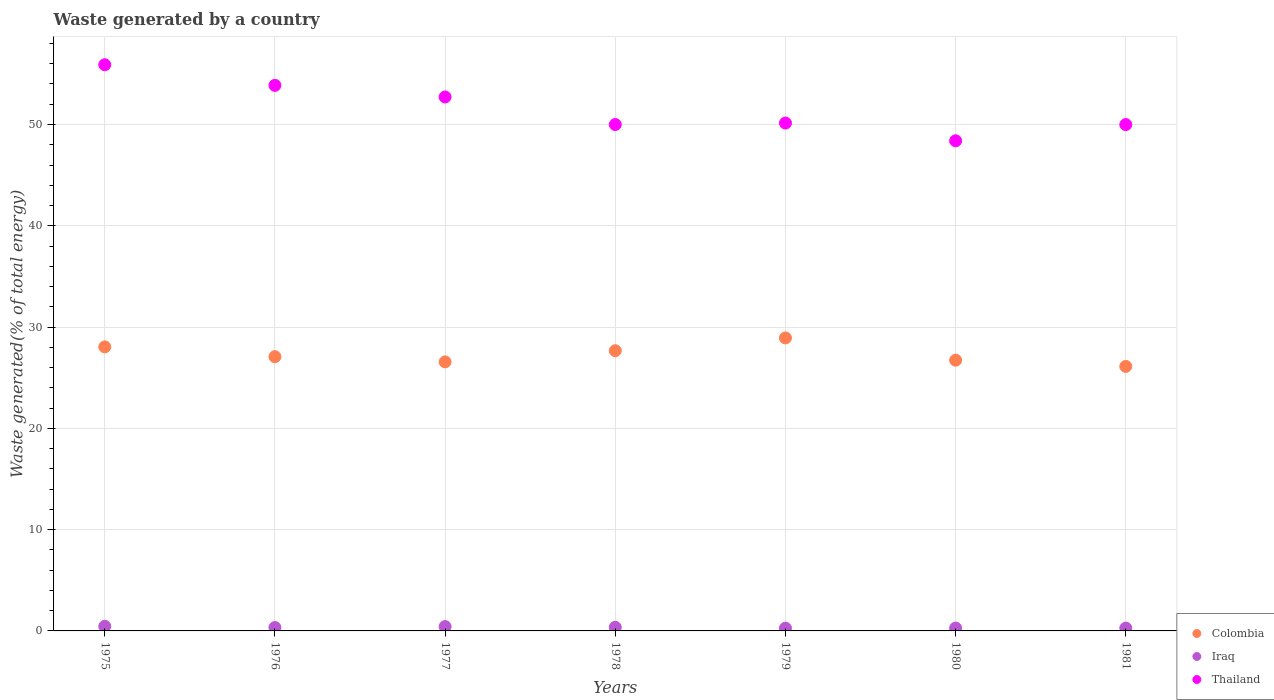Is the number of dotlines equal to the number of legend labels?
Your response must be concise. Yes. What is the total waste generated in Iraq in 1976?
Offer a very short reply. 0.34. Across all years, what is the maximum total waste generated in Colombia?
Offer a very short reply. 28.93. Across all years, what is the minimum total waste generated in Iraq?
Your response must be concise. 0.27. In which year was the total waste generated in Iraq maximum?
Offer a very short reply. 1975. What is the total total waste generated in Iraq in the graph?
Your response must be concise. 2.41. What is the difference between the total waste generated in Colombia in 1975 and that in 1979?
Offer a very short reply. -0.88. What is the difference between the total waste generated in Thailand in 1979 and the total waste generated in Colombia in 1978?
Keep it short and to the point. 22.47. What is the average total waste generated in Thailand per year?
Make the answer very short. 51.57. In the year 1978, what is the difference between the total waste generated in Thailand and total waste generated in Colombia?
Provide a succinct answer. 22.33. In how many years, is the total waste generated in Colombia greater than 10 %?
Give a very brief answer. 7. What is the ratio of the total waste generated in Iraq in 1977 to that in 1981?
Keep it short and to the point. 1.55. What is the difference between the highest and the second highest total waste generated in Thailand?
Ensure brevity in your answer.  2.04. What is the difference between the highest and the lowest total waste generated in Thailand?
Offer a very short reply. 7.51. In how many years, is the total waste generated in Iraq greater than the average total waste generated in Iraq taken over all years?
Provide a succinct answer. 3. Is the sum of the total waste generated in Iraq in 1979 and 1981 greater than the maximum total waste generated in Colombia across all years?
Your response must be concise. No. Is the total waste generated in Iraq strictly greater than the total waste generated in Colombia over the years?
Your response must be concise. No. Is the total waste generated in Thailand strictly less than the total waste generated in Colombia over the years?
Your response must be concise. No. How many dotlines are there?
Your response must be concise. 3. How many years are there in the graph?
Ensure brevity in your answer.  7. What is the difference between two consecutive major ticks on the Y-axis?
Ensure brevity in your answer.  10. Where does the legend appear in the graph?
Provide a short and direct response. Bottom right. How many legend labels are there?
Ensure brevity in your answer.  3. What is the title of the graph?
Offer a terse response. Waste generated by a country. What is the label or title of the Y-axis?
Your response must be concise. Waste generated(% of total energy). What is the Waste generated(% of total energy) of Colombia in 1975?
Provide a succinct answer. 28.04. What is the Waste generated(% of total energy) in Iraq in 1975?
Your answer should be compact. 0.45. What is the Waste generated(% of total energy) of Thailand in 1975?
Provide a succinct answer. 55.9. What is the Waste generated(% of total energy) of Colombia in 1976?
Offer a very short reply. 27.08. What is the Waste generated(% of total energy) in Iraq in 1976?
Your answer should be compact. 0.34. What is the Waste generated(% of total energy) in Thailand in 1976?
Keep it short and to the point. 53.86. What is the Waste generated(% of total energy) in Colombia in 1977?
Offer a terse response. 26.56. What is the Waste generated(% of total energy) of Iraq in 1977?
Keep it short and to the point. 0.43. What is the Waste generated(% of total energy) of Thailand in 1977?
Give a very brief answer. 52.72. What is the Waste generated(% of total energy) in Colombia in 1978?
Keep it short and to the point. 27.67. What is the Waste generated(% of total energy) of Iraq in 1978?
Offer a terse response. 0.36. What is the Waste generated(% of total energy) in Thailand in 1978?
Your answer should be compact. 50. What is the Waste generated(% of total energy) of Colombia in 1979?
Make the answer very short. 28.93. What is the Waste generated(% of total energy) in Iraq in 1979?
Keep it short and to the point. 0.27. What is the Waste generated(% of total energy) of Thailand in 1979?
Your answer should be compact. 50.14. What is the Waste generated(% of total energy) of Colombia in 1980?
Provide a succinct answer. 26.73. What is the Waste generated(% of total energy) in Iraq in 1980?
Provide a short and direct response. 0.28. What is the Waste generated(% of total energy) of Thailand in 1980?
Give a very brief answer. 48.39. What is the Waste generated(% of total energy) in Colombia in 1981?
Give a very brief answer. 26.12. What is the Waste generated(% of total energy) in Iraq in 1981?
Keep it short and to the point. 0.28. What is the Waste generated(% of total energy) in Thailand in 1981?
Offer a terse response. 49.99. Across all years, what is the maximum Waste generated(% of total energy) in Colombia?
Offer a terse response. 28.93. Across all years, what is the maximum Waste generated(% of total energy) of Iraq?
Give a very brief answer. 0.45. Across all years, what is the maximum Waste generated(% of total energy) in Thailand?
Ensure brevity in your answer.  55.9. Across all years, what is the minimum Waste generated(% of total energy) of Colombia?
Your answer should be very brief. 26.12. Across all years, what is the minimum Waste generated(% of total energy) of Iraq?
Offer a very short reply. 0.27. Across all years, what is the minimum Waste generated(% of total energy) of Thailand?
Offer a terse response. 48.39. What is the total Waste generated(% of total energy) in Colombia in the graph?
Keep it short and to the point. 191.12. What is the total Waste generated(% of total energy) of Iraq in the graph?
Your response must be concise. 2.41. What is the total Waste generated(% of total energy) in Thailand in the graph?
Give a very brief answer. 361. What is the difference between the Waste generated(% of total energy) of Colombia in 1975 and that in 1976?
Your answer should be compact. 0.97. What is the difference between the Waste generated(% of total energy) of Iraq in 1975 and that in 1976?
Your answer should be very brief. 0.12. What is the difference between the Waste generated(% of total energy) in Thailand in 1975 and that in 1976?
Give a very brief answer. 2.04. What is the difference between the Waste generated(% of total energy) in Colombia in 1975 and that in 1977?
Make the answer very short. 1.48. What is the difference between the Waste generated(% of total energy) in Iraq in 1975 and that in 1977?
Keep it short and to the point. 0.02. What is the difference between the Waste generated(% of total energy) in Thailand in 1975 and that in 1977?
Keep it short and to the point. 3.18. What is the difference between the Waste generated(% of total energy) of Colombia in 1975 and that in 1978?
Your response must be concise. 0.38. What is the difference between the Waste generated(% of total energy) of Iraq in 1975 and that in 1978?
Make the answer very short. 0.1. What is the difference between the Waste generated(% of total energy) of Thailand in 1975 and that in 1978?
Ensure brevity in your answer.  5.9. What is the difference between the Waste generated(% of total energy) of Colombia in 1975 and that in 1979?
Make the answer very short. -0.88. What is the difference between the Waste generated(% of total energy) in Iraq in 1975 and that in 1979?
Give a very brief answer. 0.18. What is the difference between the Waste generated(% of total energy) of Thailand in 1975 and that in 1979?
Provide a succinct answer. 5.76. What is the difference between the Waste generated(% of total energy) in Colombia in 1975 and that in 1980?
Your response must be concise. 1.31. What is the difference between the Waste generated(% of total energy) in Iraq in 1975 and that in 1980?
Give a very brief answer. 0.17. What is the difference between the Waste generated(% of total energy) of Thailand in 1975 and that in 1980?
Keep it short and to the point. 7.51. What is the difference between the Waste generated(% of total energy) in Colombia in 1975 and that in 1981?
Ensure brevity in your answer.  1.93. What is the difference between the Waste generated(% of total energy) of Iraq in 1975 and that in 1981?
Keep it short and to the point. 0.18. What is the difference between the Waste generated(% of total energy) of Thailand in 1975 and that in 1981?
Ensure brevity in your answer.  5.91. What is the difference between the Waste generated(% of total energy) of Colombia in 1976 and that in 1977?
Offer a very short reply. 0.51. What is the difference between the Waste generated(% of total energy) of Iraq in 1976 and that in 1977?
Your answer should be very brief. -0.1. What is the difference between the Waste generated(% of total energy) of Thailand in 1976 and that in 1977?
Your answer should be very brief. 1.15. What is the difference between the Waste generated(% of total energy) of Colombia in 1976 and that in 1978?
Provide a short and direct response. -0.59. What is the difference between the Waste generated(% of total energy) in Iraq in 1976 and that in 1978?
Provide a short and direct response. -0.02. What is the difference between the Waste generated(% of total energy) of Thailand in 1976 and that in 1978?
Make the answer very short. 3.87. What is the difference between the Waste generated(% of total energy) of Colombia in 1976 and that in 1979?
Ensure brevity in your answer.  -1.85. What is the difference between the Waste generated(% of total energy) in Iraq in 1976 and that in 1979?
Ensure brevity in your answer.  0.06. What is the difference between the Waste generated(% of total energy) in Thailand in 1976 and that in 1979?
Provide a succinct answer. 3.72. What is the difference between the Waste generated(% of total energy) in Colombia in 1976 and that in 1980?
Your response must be concise. 0.35. What is the difference between the Waste generated(% of total energy) of Iraq in 1976 and that in 1980?
Your answer should be very brief. 0.05. What is the difference between the Waste generated(% of total energy) in Thailand in 1976 and that in 1980?
Ensure brevity in your answer.  5.47. What is the difference between the Waste generated(% of total energy) in Colombia in 1976 and that in 1981?
Give a very brief answer. 0.96. What is the difference between the Waste generated(% of total energy) of Iraq in 1976 and that in 1981?
Your answer should be very brief. 0.06. What is the difference between the Waste generated(% of total energy) in Thailand in 1976 and that in 1981?
Your answer should be compact. 3.87. What is the difference between the Waste generated(% of total energy) in Colombia in 1977 and that in 1978?
Offer a very short reply. -1.1. What is the difference between the Waste generated(% of total energy) in Iraq in 1977 and that in 1978?
Keep it short and to the point. 0.07. What is the difference between the Waste generated(% of total energy) of Thailand in 1977 and that in 1978?
Provide a succinct answer. 2.72. What is the difference between the Waste generated(% of total energy) of Colombia in 1977 and that in 1979?
Your answer should be very brief. -2.36. What is the difference between the Waste generated(% of total energy) of Iraq in 1977 and that in 1979?
Provide a succinct answer. 0.16. What is the difference between the Waste generated(% of total energy) of Thailand in 1977 and that in 1979?
Your answer should be compact. 2.57. What is the difference between the Waste generated(% of total energy) in Colombia in 1977 and that in 1980?
Keep it short and to the point. -0.17. What is the difference between the Waste generated(% of total energy) in Iraq in 1977 and that in 1980?
Make the answer very short. 0.15. What is the difference between the Waste generated(% of total energy) in Thailand in 1977 and that in 1980?
Provide a succinct answer. 4.33. What is the difference between the Waste generated(% of total energy) of Colombia in 1977 and that in 1981?
Ensure brevity in your answer.  0.45. What is the difference between the Waste generated(% of total energy) in Iraq in 1977 and that in 1981?
Make the answer very short. 0.15. What is the difference between the Waste generated(% of total energy) in Thailand in 1977 and that in 1981?
Offer a terse response. 2.73. What is the difference between the Waste generated(% of total energy) in Colombia in 1978 and that in 1979?
Offer a terse response. -1.26. What is the difference between the Waste generated(% of total energy) of Iraq in 1978 and that in 1979?
Provide a succinct answer. 0.09. What is the difference between the Waste generated(% of total energy) of Thailand in 1978 and that in 1979?
Make the answer very short. -0.14. What is the difference between the Waste generated(% of total energy) in Colombia in 1978 and that in 1980?
Provide a succinct answer. 0.94. What is the difference between the Waste generated(% of total energy) of Iraq in 1978 and that in 1980?
Your answer should be very brief. 0.08. What is the difference between the Waste generated(% of total energy) of Thailand in 1978 and that in 1980?
Ensure brevity in your answer.  1.61. What is the difference between the Waste generated(% of total energy) of Colombia in 1978 and that in 1981?
Your response must be concise. 1.55. What is the difference between the Waste generated(% of total energy) in Iraq in 1978 and that in 1981?
Offer a very short reply. 0.08. What is the difference between the Waste generated(% of total energy) in Thailand in 1978 and that in 1981?
Provide a succinct answer. 0.01. What is the difference between the Waste generated(% of total energy) in Colombia in 1979 and that in 1980?
Provide a short and direct response. 2.2. What is the difference between the Waste generated(% of total energy) of Iraq in 1979 and that in 1980?
Your response must be concise. -0.01. What is the difference between the Waste generated(% of total energy) of Thailand in 1979 and that in 1980?
Make the answer very short. 1.75. What is the difference between the Waste generated(% of total energy) in Colombia in 1979 and that in 1981?
Your answer should be very brief. 2.81. What is the difference between the Waste generated(% of total energy) of Iraq in 1979 and that in 1981?
Offer a very short reply. -0.01. What is the difference between the Waste generated(% of total energy) in Thailand in 1979 and that in 1981?
Your answer should be very brief. 0.15. What is the difference between the Waste generated(% of total energy) of Colombia in 1980 and that in 1981?
Ensure brevity in your answer.  0.61. What is the difference between the Waste generated(% of total energy) in Iraq in 1980 and that in 1981?
Give a very brief answer. 0.01. What is the difference between the Waste generated(% of total energy) of Thailand in 1980 and that in 1981?
Your answer should be very brief. -1.6. What is the difference between the Waste generated(% of total energy) of Colombia in 1975 and the Waste generated(% of total energy) of Iraq in 1976?
Your answer should be compact. 27.71. What is the difference between the Waste generated(% of total energy) in Colombia in 1975 and the Waste generated(% of total energy) in Thailand in 1976?
Ensure brevity in your answer.  -25.82. What is the difference between the Waste generated(% of total energy) of Iraq in 1975 and the Waste generated(% of total energy) of Thailand in 1976?
Provide a succinct answer. -53.41. What is the difference between the Waste generated(% of total energy) of Colombia in 1975 and the Waste generated(% of total energy) of Iraq in 1977?
Offer a very short reply. 27.61. What is the difference between the Waste generated(% of total energy) of Colombia in 1975 and the Waste generated(% of total energy) of Thailand in 1977?
Your response must be concise. -24.67. What is the difference between the Waste generated(% of total energy) in Iraq in 1975 and the Waste generated(% of total energy) in Thailand in 1977?
Give a very brief answer. -52.26. What is the difference between the Waste generated(% of total energy) of Colombia in 1975 and the Waste generated(% of total energy) of Iraq in 1978?
Offer a terse response. 27.68. What is the difference between the Waste generated(% of total energy) of Colombia in 1975 and the Waste generated(% of total energy) of Thailand in 1978?
Provide a succinct answer. -21.95. What is the difference between the Waste generated(% of total energy) in Iraq in 1975 and the Waste generated(% of total energy) in Thailand in 1978?
Ensure brevity in your answer.  -49.54. What is the difference between the Waste generated(% of total energy) of Colombia in 1975 and the Waste generated(% of total energy) of Iraq in 1979?
Provide a short and direct response. 27.77. What is the difference between the Waste generated(% of total energy) in Colombia in 1975 and the Waste generated(% of total energy) in Thailand in 1979?
Ensure brevity in your answer.  -22.1. What is the difference between the Waste generated(% of total energy) of Iraq in 1975 and the Waste generated(% of total energy) of Thailand in 1979?
Provide a short and direct response. -49.69. What is the difference between the Waste generated(% of total energy) of Colombia in 1975 and the Waste generated(% of total energy) of Iraq in 1980?
Your response must be concise. 27.76. What is the difference between the Waste generated(% of total energy) in Colombia in 1975 and the Waste generated(% of total energy) in Thailand in 1980?
Ensure brevity in your answer.  -20.35. What is the difference between the Waste generated(% of total energy) in Iraq in 1975 and the Waste generated(% of total energy) in Thailand in 1980?
Ensure brevity in your answer.  -47.94. What is the difference between the Waste generated(% of total energy) of Colombia in 1975 and the Waste generated(% of total energy) of Iraq in 1981?
Offer a terse response. 27.77. What is the difference between the Waste generated(% of total energy) of Colombia in 1975 and the Waste generated(% of total energy) of Thailand in 1981?
Provide a succinct answer. -21.95. What is the difference between the Waste generated(% of total energy) in Iraq in 1975 and the Waste generated(% of total energy) in Thailand in 1981?
Your answer should be very brief. -49.54. What is the difference between the Waste generated(% of total energy) in Colombia in 1976 and the Waste generated(% of total energy) in Iraq in 1977?
Your answer should be very brief. 26.65. What is the difference between the Waste generated(% of total energy) in Colombia in 1976 and the Waste generated(% of total energy) in Thailand in 1977?
Give a very brief answer. -25.64. What is the difference between the Waste generated(% of total energy) in Iraq in 1976 and the Waste generated(% of total energy) in Thailand in 1977?
Keep it short and to the point. -52.38. What is the difference between the Waste generated(% of total energy) in Colombia in 1976 and the Waste generated(% of total energy) in Iraq in 1978?
Your response must be concise. 26.72. What is the difference between the Waste generated(% of total energy) of Colombia in 1976 and the Waste generated(% of total energy) of Thailand in 1978?
Offer a very short reply. -22.92. What is the difference between the Waste generated(% of total energy) of Iraq in 1976 and the Waste generated(% of total energy) of Thailand in 1978?
Offer a very short reply. -49.66. What is the difference between the Waste generated(% of total energy) of Colombia in 1976 and the Waste generated(% of total energy) of Iraq in 1979?
Provide a succinct answer. 26.8. What is the difference between the Waste generated(% of total energy) in Colombia in 1976 and the Waste generated(% of total energy) in Thailand in 1979?
Provide a succinct answer. -23.07. What is the difference between the Waste generated(% of total energy) in Iraq in 1976 and the Waste generated(% of total energy) in Thailand in 1979?
Provide a short and direct response. -49.81. What is the difference between the Waste generated(% of total energy) in Colombia in 1976 and the Waste generated(% of total energy) in Iraq in 1980?
Your answer should be very brief. 26.79. What is the difference between the Waste generated(% of total energy) of Colombia in 1976 and the Waste generated(% of total energy) of Thailand in 1980?
Give a very brief answer. -21.31. What is the difference between the Waste generated(% of total energy) of Iraq in 1976 and the Waste generated(% of total energy) of Thailand in 1980?
Provide a short and direct response. -48.06. What is the difference between the Waste generated(% of total energy) in Colombia in 1976 and the Waste generated(% of total energy) in Iraq in 1981?
Give a very brief answer. 26.8. What is the difference between the Waste generated(% of total energy) of Colombia in 1976 and the Waste generated(% of total energy) of Thailand in 1981?
Your answer should be very brief. -22.92. What is the difference between the Waste generated(% of total energy) in Iraq in 1976 and the Waste generated(% of total energy) in Thailand in 1981?
Give a very brief answer. -49.66. What is the difference between the Waste generated(% of total energy) of Colombia in 1977 and the Waste generated(% of total energy) of Iraq in 1978?
Provide a succinct answer. 26.2. What is the difference between the Waste generated(% of total energy) in Colombia in 1977 and the Waste generated(% of total energy) in Thailand in 1978?
Your answer should be compact. -23.44. What is the difference between the Waste generated(% of total energy) in Iraq in 1977 and the Waste generated(% of total energy) in Thailand in 1978?
Your answer should be compact. -49.57. What is the difference between the Waste generated(% of total energy) in Colombia in 1977 and the Waste generated(% of total energy) in Iraq in 1979?
Ensure brevity in your answer.  26.29. What is the difference between the Waste generated(% of total energy) in Colombia in 1977 and the Waste generated(% of total energy) in Thailand in 1979?
Ensure brevity in your answer.  -23.58. What is the difference between the Waste generated(% of total energy) of Iraq in 1977 and the Waste generated(% of total energy) of Thailand in 1979?
Keep it short and to the point. -49.71. What is the difference between the Waste generated(% of total energy) of Colombia in 1977 and the Waste generated(% of total energy) of Iraq in 1980?
Give a very brief answer. 26.28. What is the difference between the Waste generated(% of total energy) in Colombia in 1977 and the Waste generated(% of total energy) in Thailand in 1980?
Keep it short and to the point. -21.83. What is the difference between the Waste generated(% of total energy) of Iraq in 1977 and the Waste generated(% of total energy) of Thailand in 1980?
Offer a very short reply. -47.96. What is the difference between the Waste generated(% of total energy) in Colombia in 1977 and the Waste generated(% of total energy) in Iraq in 1981?
Your answer should be compact. 26.29. What is the difference between the Waste generated(% of total energy) in Colombia in 1977 and the Waste generated(% of total energy) in Thailand in 1981?
Make the answer very short. -23.43. What is the difference between the Waste generated(% of total energy) of Iraq in 1977 and the Waste generated(% of total energy) of Thailand in 1981?
Make the answer very short. -49.56. What is the difference between the Waste generated(% of total energy) in Colombia in 1978 and the Waste generated(% of total energy) in Iraq in 1979?
Offer a very short reply. 27.4. What is the difference between the Waste generated(% of total energy) of Colombia in 1978 and the Waste generated(% of total energy) of Thailand in 1979?
Keep it short and to the point. -22.48. What is the difference between the Waste generated(% of total energy) of Iraq in 1978 and the Waste generated(% of total energy) of Thailand in 1979?
Provide a short and direct response. -49.78. What is the difference between the Waste generated(% of total energy) in Colombia in 1978 and the Waste generated(% of total energy) in Iraq in 1980?
Your answer should be very brief. 27.38. What is the difference between the Waste generated(% of total energy) in Colombia in 1978 and the Waste generated(% of total energy) in Thailand in 1980?
Ensure brevity in your answer.  -20.72. What is the difference between the Waste generated(% of total energy) of Iraq in 1978 and the Waste generated(% of total energy) of Thailand in 1980?
Keep it short and to the point. -48.03. What is the difference between the Waste generated(% of total energy) of Colombia in 1978 and the Waste generated(% of total energy) of Iraq in 1981?
Your response must be concise. 27.39. What is the difference between the Waste generated(% of total energy) of Colombia in 1978 and the Waste generated(% of total energy) of Thailand in 1981?
Provide a short and direct response. -22.32. What is the difference between the Waste generated(% of total energy) of Iraq in 1978 and the Waste generated(% of total energy) of Thailand in 1981?
Ensure brevity in your answer.  -49.63. What is the difference between the Waste generated(% of total energy) in Colombia in 1979 and the Waste generated(% of total energy) in Iraq in 1980?
Your answer should be compact. 28.64. What is the difference between the Waste generated(% of total energy) in Colombia in 1979 and the Waste generated(% of total energy) in Thailand in 1980?
Provide a succinct answer. -19.46. What is the difference between the Waste generated(% of total energy) of Iraq in 1979 and the Waste generated(% of total energy) of Thailand in 1980?
Give a very brief answer. -48.12. What is the difference between the Waste generated(% of total energy) of Colombia in 1979 and the Waste generated(% of total energy) of Iraq in 1981?
Make the answer very short. 28.65. What is the difference between the Waste generated(% of total energy) in Colombia in 1979 and the Waste generated(% of total energy) in Thailand in 1981?
Give a very brief answer. -21.06. What is the difference between the Waste generated(% of total energy) of Iraq in 1979 and the Waste generated(% of total energy) of Thailand in 1981?
Offer a very short reply. -49.72. What is the difference between the Waste generated(% of total energy) in Colombia in 1980 and the Waste generated(% of total energy) in Iraq in 1981?
Your response must be concise. 26.45. What is the difference between the Waste generated(% of total energy) of Colombia in 1980 and the Waste generated(% of total energy) of Thailand in 1981?
Give a very brief answer. -23.26. What is the difference between the Waste generated(% of total energy) in Iraq in 1980 and the Waste generated(% of total energy) in Thailand in 1981?
Ensure brevity in your answer.  -49.71. What is the average Waste generated(% of total energy) in Colombia per year?
Offer a terse response. 27.3. What is the average Waste generated(% of total energy) of Iraq per year?
Your response must be concise. 0.34. What is the average Waste generated(% of total energy) in Thailand per year?
Keep it short and to the point. 51.57. In the year 1975, what is the difference between the Waste generated(% of total energy) of Colombia and Waste generated(% of total energy) of Iraq?
Make the answer very short. 27.59. In the year 1975, what is the difference between the Waste generated(% of total energy) in Colombia and Waste generated(% of total energy) in Thailand?
Offer a very short reply. -27.86. In the year 1975, what is the difference between the Waste generated(% of total energy) in Iraq and Waste generated(% of total energy) in Thailand?
Provide a succinct answer. -55.44. In the year 1976, what is the difference between the Waste generated(% of total energy) in Colombia and Waste generated(% of total energy) in Iraq?
Give a very brief answer. 26.74. In the year 1976, what is the difference between the Waste generated(% of total energy) of Colombia and Waste generated(% of total energy) of Thailand?
Provide a short and direct response. -26.79. In the year 1976, what is the difference between the Waste generated(% of total energy) of Iraq and Waste generated(% of total energy) of Thailand?
Ensure brevity in your answer.  -53.53. In the year 1977, what is the difference between the Waste generated(% of total energy) in Colombia and Waste generated(% of total energy) in Iraq?
Keep it short and to the point. 26.13. In the year 1977, what is the difference between the Waste generated(% of total energy) in Colombia and Waste generated(% of total energy) in Thailand?
Keep it short and to the point. -26.15. In the year 1977, what is the difference between the Waste generated(% of total energy) in Iraq and Waste generated(% of total energy) in Thailand?
Provide a short and direct response. -52.29. In the year 1978, what is the difference between the Waste generated(% of total energy) of Colombia and Waste generated(% of total energy) of Iraq?
Your answer should be very brief. 27.31. In the year 1978, what is the difference between the Waste generated(% of total energy) of Colombia and Waste generated(% of total energy) of Thailand?
Provide a short and direct response. -22.33. In the year 1978, what is the difference between the Waste generated(% of total energy) in Iraq and Waste generated(% of total energy) in Thailand?
Ensure brevity in your answer.  -49.64. In the year 1979, what is the difference between the Waste generated(% of total energy) of Colombia and Waste generated(% of total energy) of Iraq?
Offer a terse response. 28.66. In the year 1979, what is the difference between the Waste generated(% of total energy) of Colombia and Waste generated(% of total energy) of Thailand?
Ensure brevity in your answer.  -21.22. In the year 1979, what is the difference between the Waste generated(% of total energy) in Iraq and Waste generated(% of total energy) in Thailand?
Offer a very short reply. -49.87. In the year 1980, what is the difference between the Waste generated(% of total energy) in Colombia and Waste generated(% of total energy) in Iraq?
Offer a very short reply. 26.45. In the year 1980, what is the difference between the Waste generated(% of total energy) of Colombia and Waste generated(% of total energy) of Thailand?
Provide a short and direct response. -21.66. In the year 1980, what is the difference between the Waste generated(% of total energy) of Iraq and Waste generated(% of total energy) of Thailand?
Give a very brief answer. -48.11. In the year 1981, what is the difference between the Waste generated(% of total energy) in Colombia and Waste generated(% of total energy) in Iraq?
Offer a terse response. 25.84. In the year 1981, what is the difference between the Waste generated(% of total energy) in Colombia and Waste generated(% of total energy) in Thailand?
Offer a terse response. -23.88. In the year 1981, what is the difference between the Waste generated(% of total energy) in Iraq and Waste generated(% of total energy) in Thailand?
Make the answer very short. -49.71. What is the ratio of the Waste generated(% of total energy) in Colombia in 1975 to that in 1976?
Make the answer very short. 1.04. What is the ratio of the Waste generated(% of total energy) of Iraq in 1975 to that in 1976?
Give a very brief answer. 1.35. What is the ratio of the Waste generated(% of total energy) of Thailand in 1975 to that in 1976?
Your response must be concise. 1.04. What is the ratio of the Waste generated(% of total energy) in Colombia in 1975 to that in 1977?
Provide a succinct answer. 1.06. What is the ratio of the Waste generated(% of total energy) in Iraq in 1975 to that in 1977?
Provide a short and direct response. 1.06. What is the ratio of the Waste generated(% of total energy) of Thailand in 1975 to that in 1977?
Offer a very short reply. 1.06. What is the ratio of the Waste generated(% of total energy) in Colombia in 1975 to that in 1978?
Provide a short and direct response. 1.01. What is the ratio of the Waste generated(% of total energy) of Iraq in 1975 to that in 1978?
Make the answer very short. 1.27. What is the ratio of the Waste generated(% of total energy) in Thailand in 1975 to that in 1978?
Offer a very short reply. 1.12. What is the ratio of the Waste generated(% of total energy) of Colombia in 1975 to that in 1979?
Your answer should be very brief. 0.97. What is the ratio of the Waste generated(% of total energy) of Iraq in 1975 to that in 1979?
Your response must be concise. 1.68. What is the ratio of the Waste generated(% of total energy) in Thailand in 1975 to that in 1979?
Provide a short and direct response. 1.11. What is the ratio of the Waste generated(% of total energy) of Colombia in 1975 to that in 1980?
Your answer should be compact. 1.05. What is the ratio of the Waste generated(% of total energy) of Iraq in 1975 to that in 1980?
Your response must be concise. 1.61. What is the ratio of the Waste generated(% of total energy) in Thailand in 1975 to that in 1980?
Make the answer very short. 1.16. What is the ratio of the Waste generated(% of total energy) in Colombia in 1975 to that in 1981?
Provide a short and direct response. 1.07. What is the ratio of the Waste generated(% of total energy) of Iraq in 1975 to that in 1981?
Your answer should be very brief. 1.64. What is the ratio of the Waste generated(% of total energy) of Thailand in 1975 to that in 1981?
Give a very brief answer. 1.12. What is the ratio of the Waste generated(% of total energy) of Colombia in 1976 to that in 1977?
Make the answer very short. 1.02. What is the ratio of the Waste generated(% of total energy) in Iraq in 1976 to that in 1977?
Make the answer very short. 0.78. What is the ratio of the Waste generated(% of total energy) of Thailand in 1976 to that in 1977?
Ensure brevity in your answer.  1.02. What is the ratio of the Waste generated(% of total energy) of Colombia in 1976 to that in 1978?
Offer a terse response. 0.98. What is the ratio of the Waste generated(% of total energy) in Iraq in 1976 to that in 1978?
Your answer should be very brief. 0.93. What is the ratio of the Waste generated(% of total energy) of Thailand in 1976 to that in 1978?
Your answer should be very brief. 1.08. What is the ratio of the Waste generated(% of total energy) in Colombia in 1976 to that in 1979?
Your response must be concise. 0.94. What is the ratio of the Waste generated(% of total energy) of Iraq in 1976 to that in 1979?
Offer a very short reply. 1.24. What is the ratio of the Waste generated(% of total energy) of Thailand in 1976 to that in 1979?
Provide a succinct answer. 1.07. What is the ratio of the Waste generated(% of total energy) in Iraq in 1976 to that in 1980?
Ensure brevity in your answer.  1.19. What is the ratio of the Waste generated(% of total energy) in Thailand in 1976 to that in 1980?
Your answer should be very brief. 1.11. What is the ratio of the Waste generated(% of total energy) in Colombia in 1976 to that in 1981?
Make the answer very short. 1.04. What is the ratio of the Waste generated(% of total energy) of Iraq in 1976 to that in 1981?
Ensure brevity in your answer.  1.21. What is the ratio of the Waste generated(% of total energy) in Thailand in 1976 to that in 1981?
Ensure brevity in your answer.  1.08. What is the ratio of the Waste generated(% of total energy) in Colombia in 1977 to that in 1978?
Offer a terse response. 0.96. What is the ratio of the Waste generated(% of total energy) in Iraq in 1977 to that in 1978?
Offer a very short reply. 1.2. What is the ratio of the Waste generated(% of total energy) in Thailand in 1977 to that in 1978?
Provide a short and direct response. 1.05. What is the ratio of the Waste generated(% of total energy) in Colombia in 1977 to that in 1979?
Your answer should be compact. 0.92. What is the ratio of the Waste generated(% of total energy) in Iraq in 1977 to that in 1979?
Make the answer very short. 1.59. What is the ratio of the Waste generated(% of total energy) in Thailand in 1977 to that in 1979?
Your answer should be compact. 1.05. What is the ratio of the Waste generated(% of total energy) in Colombia in 1977 to that in 1980?
Offer a very short reply. 0.99. What is the ratio of the Waste generated(% of total energy) of Iraq in 1977 to that in 1980?
Provide a succinct answer. 1.52. What is the ratio of the Waste generated(% of total energy) in Thailand in 1977 to that in 1980?
Your answer should be compact. 1.09. What is the ratio of the Waste generated(% of total energy) of Colombia in 1977 to that in 1981?
Ensure brevity in your answer.  1.02. What is the ratio of the Waste generated(% of total energy) in Iraq in 1977 to that in 1981?
Offer a terse response. 1.55. What is the ratio of the Waste generated(% of total energy) of Thailand in 1977 to that in 1981?
Give a very brief answer. 1.05. What is the ratio of the Waste generated(% of total energy) of Colombia in 1978 to that in 1979?
Make the answer very short. 0.96. What is the ratio of the Waste generated(% of total energy) of Iraq in 1978 to that in 1979?
Your response must be concise. 1.32. What is the ratio of the Waste generated(% of total energy) in Colombia in 1978 to that in 1980?
Provide a short and direct response. 1.04. What is the ratio of the Waste generated(% of total energy) of Iraq in 1978 to that in 1980?
Ensure brevity in your answer.  1.27. What is the ratio of the Waste generated(% of total energy) of Thailand in 1978 to that in 1980?
Make the answer very short. 1.03. What is the ratio of the Waste generated(% of total energy) in Colombia in 1978 to that in 1981?
Provide a succinct answer. 1.06. What is the ratio of the Waste generated(% of total energy) of Iraq in 1978 to that in 1981?
Make the answer very short. 1.3. What is the ratio of the Waste generated(% of total energy) in Thailand in 1978 to that in 1981?
Your response must be concise. 1. What is the ratio of the Waste generated(% of total energy) in Colombia in 1979 to that in 1980?
Your answer should be very brief. 1.08. What is the ratio of the Waste generated(% of total energy) in Iraq in 1979 to that in 1980?
Make the answer very short. 0.96. What is the ratio of the Waste generated(% of total energy) of Thailand in 1979 to that in 1980?
Offer a very short reply. 1.04. What is the ratio of the Waste generated(% of total energy) in Colombia in 1979 to that in 1981?
Offer a very short reply. 1.11. What is the ratio of the Waste generated(% of total energy) in Iraq in 1979 to that in 1981?
Provide a short and direct response. 0.98. What is the ratio of the Waste generated(% of total energy) of Thailand in 1979 to that in 1981?
Provide a short and direct response. 1. What is the ratio of the Waste generated(% of total energy) of Colombia in 1980 to that in 1981?
Offer a terse response. 1.02. What is the ratio of the Waste generated(% of total energy) of Iraq in 1980 to that in 1981?
Provide a succinct answer. 1.02. What is the ratio of the Waste generated(% of total energy) in Thailand in 1980 to that in 1981?
Provide a short and direct response. 0.97. What is the difference between the highest and the second highest Waste generated(% of total energy) of Colombia?
Make the answer very short. 0.88. What is the difference between the highest and the second highest Waste generated(% of total energy) in Iraq?
Provide a short and direct response. 0.02. What is the difference between the highest and the second highest Waste generated(% of total energy) in Thailand?
Offer a terse response. 2.04. What is the difference between the highest and the lowest Waste generated(% of total energy) of Colombia?
Provide a succinct answer. 2.81. What is the difference between the highest and the lowest Waste generated(% of total energy) of Iraq?
Offer a very short reply. 0.18. What is the difference between the highest and the lowest Waste generated(% of total energy) of Thailand?
Ensure brevity in your answer.  7.51. 